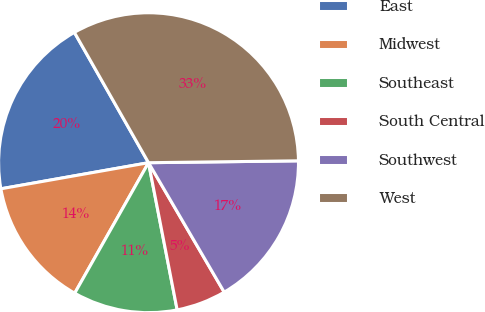Convert chart to OTSL. <chart><loc_0><loc_0><loc_500><loc_500><pie_chart><fcel>East<fcel>Midwest<fcel>Southeast<fcel>South Central<fcel>Southwest<fcel>West<nl><fcel>19.55%<fcel>14.02%<fcel>11.25%<fcel>5.36%<fcel>16.78%<fcel>33.03%<nl></chart> 